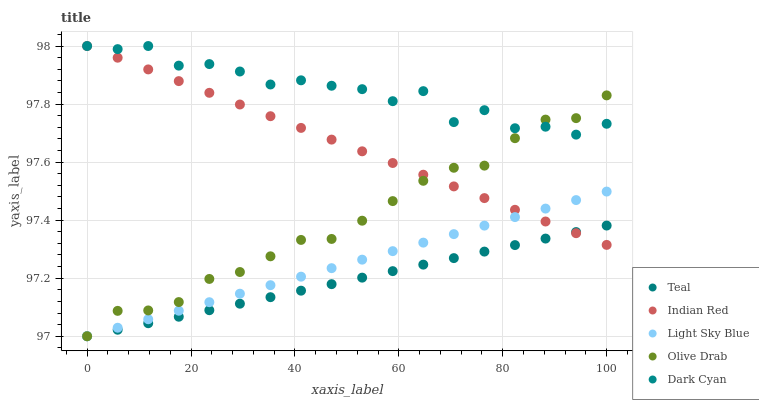Does Teal have the minimum area under the curve?
Answer yes or no. Yes. Does Dark Cyan have the maximum area under the curve?
Answer yes or no. Yes. Does Olive Drab have the minimum area under the curve?
Answer yes or no. No. Does Olive Drab have the maximum area under the curve?
Answer yes or no. No. Is Teal the smoothest?
Answer yes or no. Yes. Is Dark Cyan the roughest?
Answer yes or no. Yes. Is Olive Drab the smoothest?
Answer yes or no. No. Is Olive Drab the roughest?
Answer yes or no. No. Does Olive Drab have the lowest value?
Answer yes or no. Yes. Does Indian Red have the lowest value?
Answer yes or no. No. Does Indian Red have the highest value?
Answer yes or no. Yes. Does Olive Drab have the highest value?
Answer yes or no. No. Is Teal less than Dark Cyan?
Answer yes or no. Yes. Is Dark Cyan greater than Light Sky Blue?
Answer yes or no. Yes. Does Teal intersect Light Sky Blue?
Answer yes or no. Yes. Is Teal less than Light Sky Blue?
Answer yes or no. No. Is Teal greater than Light Sky Blue?
Answer yes or no. No. Does Teal intersect Dark Cyan?
Answer yes or no. No. 